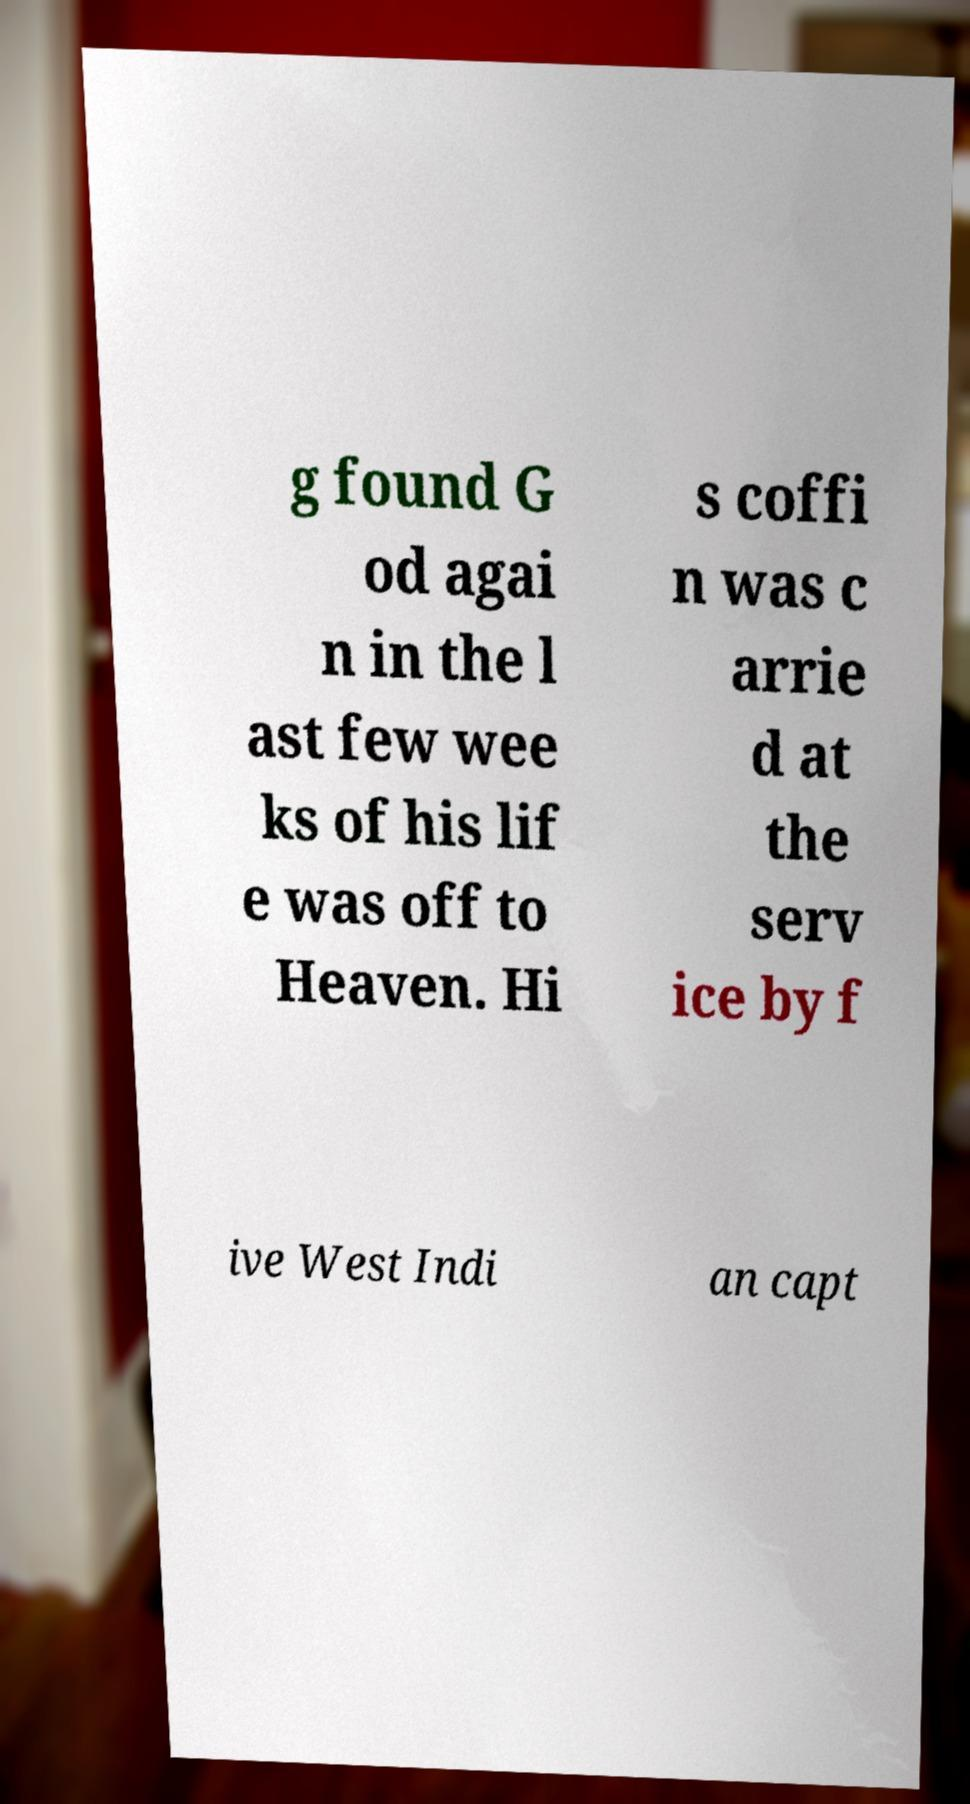For documentation purposes, I need the text within this image transcribed. Could you provide that? g found G od agai n in the l ast few wee ks of his lif e was off to Heaven. Hi s coffi n was c arrie d at the serv ice by f ive West Indi an capt 